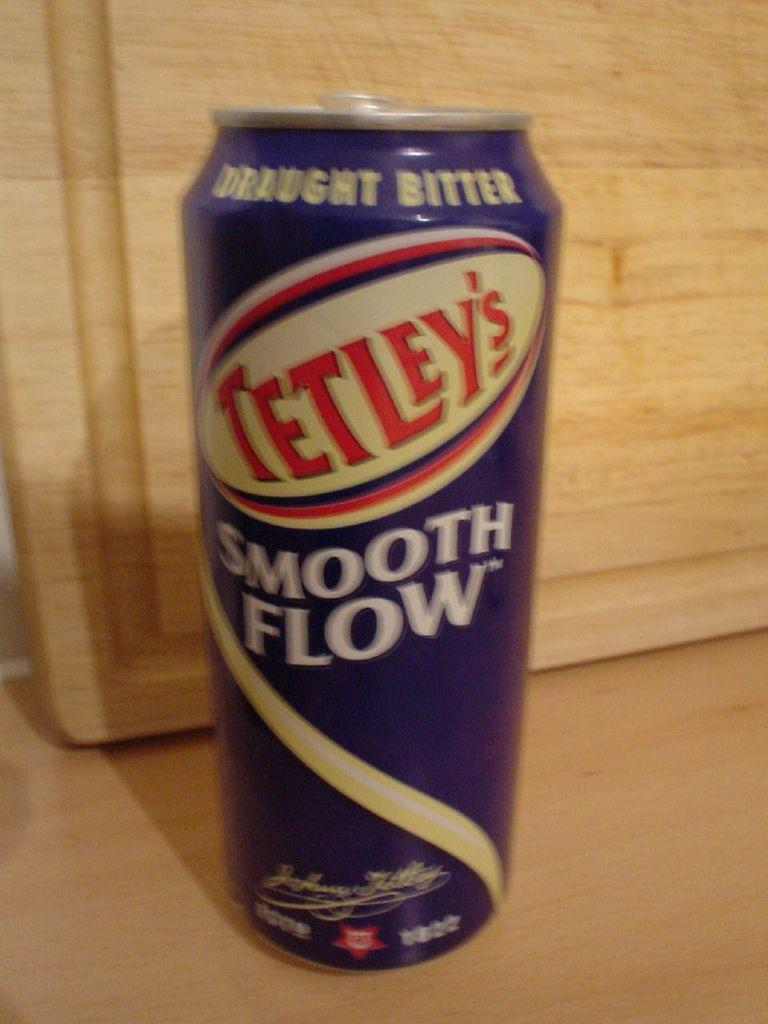<image>
Offer a succinct explanation of the picture presented. A single can of Tetley's smooth flow draught bitter is on a counter in front of a cutting board. 